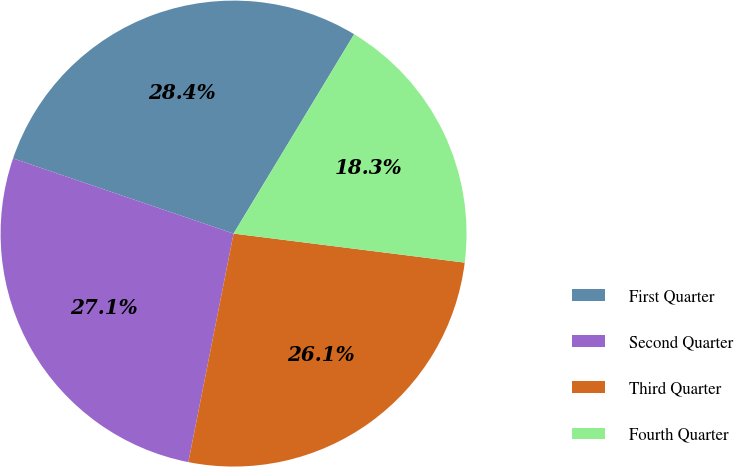<chart> <loc_0><loc_0><loc_500><loc_500><pie_chart><fcel>First Quarter<fcel>Second Quarter<fcel>Third Quarter<fcel>Fourth Quarter<nl><fcel>28.43%<fcel>27.12%<fcel>26.12%<fcel>18.33%<nl></chart> 